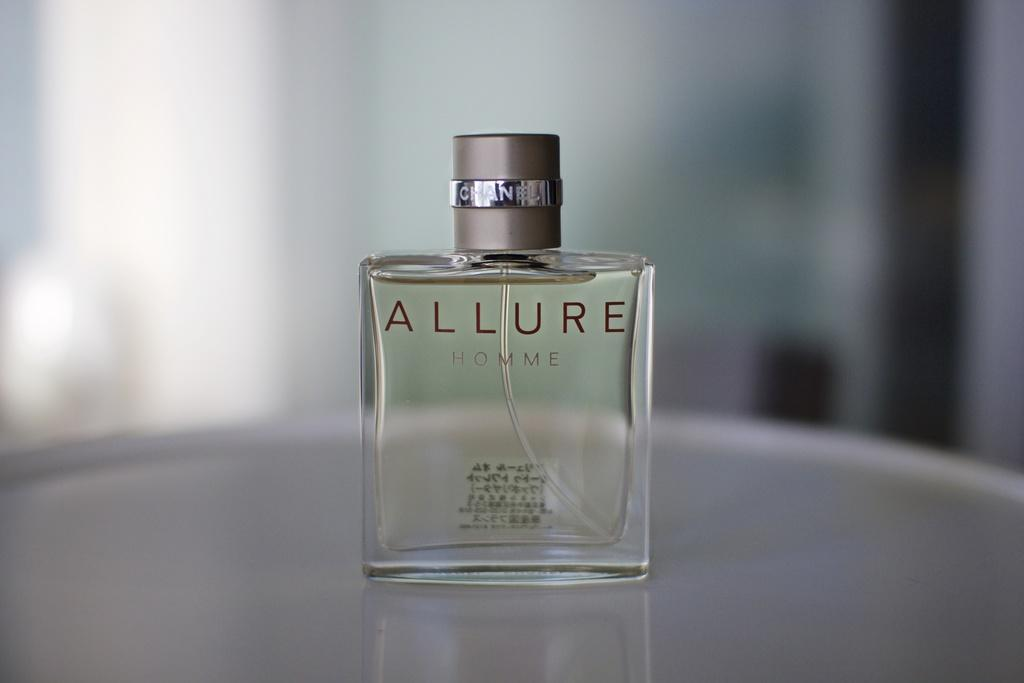<image>
Summarize the visual content of the image. Bottle of Allure for Homme on top of a table. 